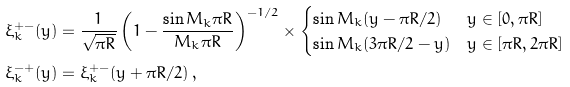Convert formula to latex. <formula><loc_0><loc_0><loc_500><loc_500>\xi ^ { + - } _ { k } ( y ) & = \frac { 1 } { \sqrt { \pi R } } \left ( 1 - \frac { \sin M _ { k } \pi R } { M _ { k } \pi R } \right ) ^ { - 1 / 2 } \times \begin{cases} \sin M _ { k } ( y - \pi R / 2 ) & y \in [ 0 , \pi R ] \\ \sin M _ { k } ( 3 \pi R / 2 - y ) & y \in [ \pi R , 2 \pi R ] \end{cases} \\ \xi ^ { - + } _ { k } ( y ) & = \xi ^ { + - } _ { k } ( y + \pi R / 2 ) \, ,</formula> 